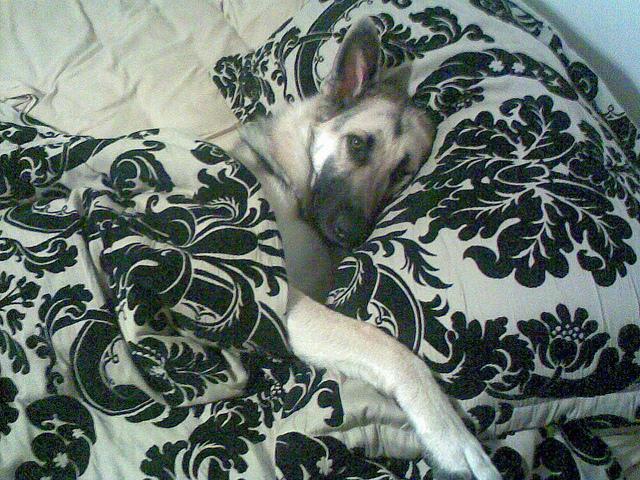What breed of dog is this?
Be succinct. German shepherd. Does the pillow match the blanket?
Quick response, please. Yes. What is this animal?
Keep it brief. Dog. Who is in the bed?
Be succinct. Dog. Is the dog sleeping?
Be succinct. No. 